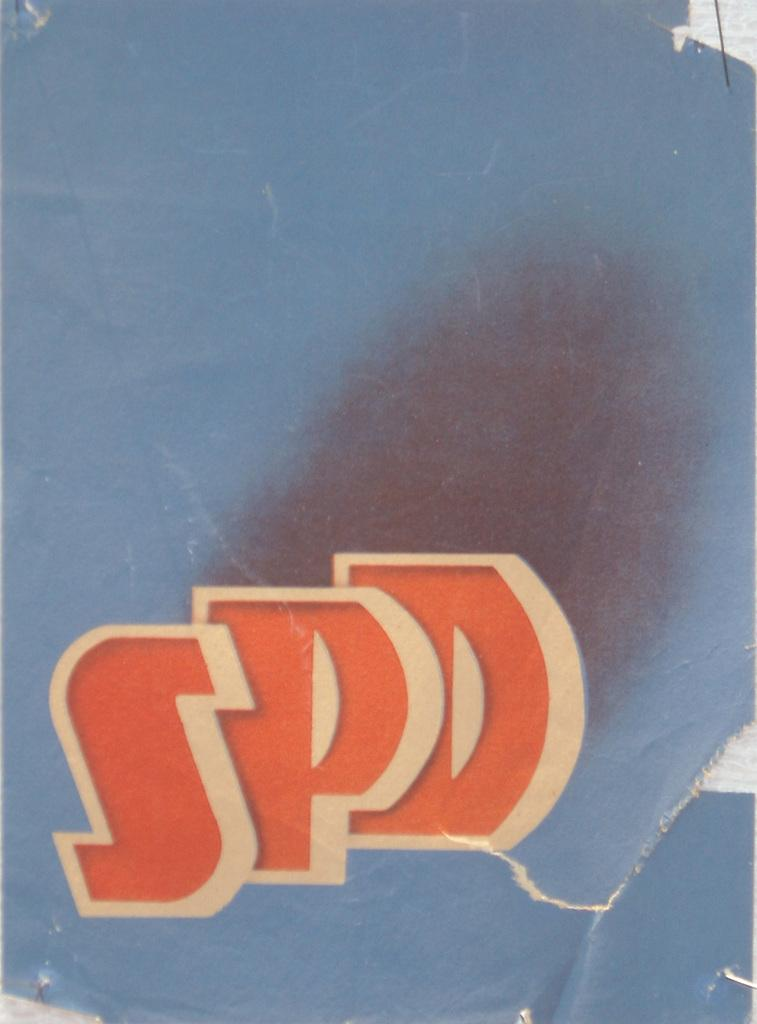<image>
Write a terse but informative summary of the picture. blue paper with several rips and letters spd in red with white outline 